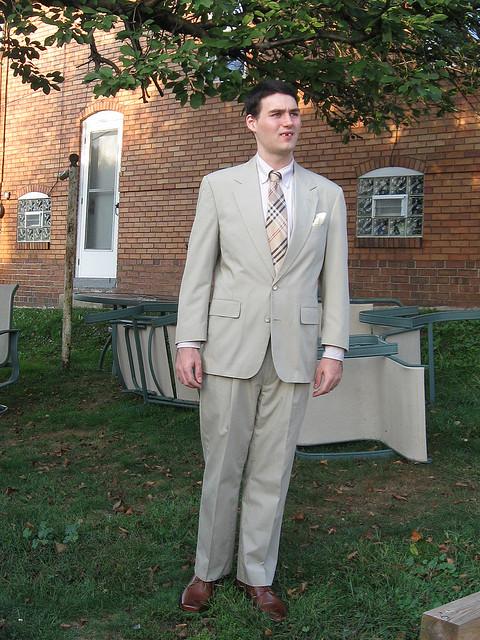Is the man wearing a tie?
Short answer required. Yes. Are there chairs laying on their sides?
Give a very brief answer. Yes. Is he standing on grass?
Answer briefly. Yes. 